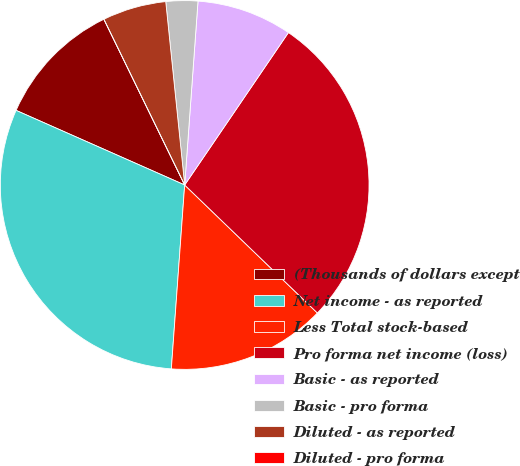<chart> <loc_0><loc_0><loc_500><loc_500><pie_chart><fcel>(Thousands of dollars except<fcel>Net income - as reported<fcel>Less Total stock-based<fcel>Pro forma net income (loss)<fcel>Basic - as reported<fcel>Basic - pro forma<fcel>Diluted - as reported<fcel>Diluted - pro forma<nl><fcel>11.15%<fcel>30.48%<fcel>13.94%<fcel>27.7%<fcel>8.36%<fcel>2.79%<fcel>5.58%<fcel>0.0%<nl></chart> 